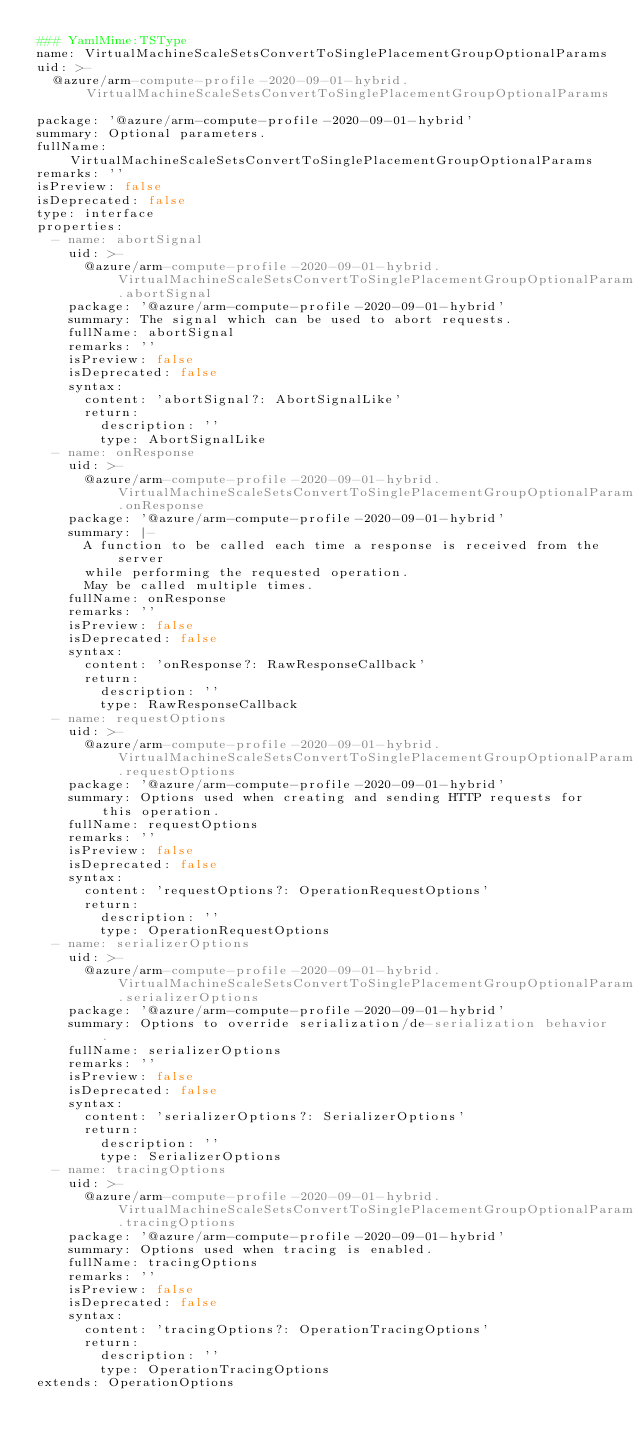Convert code to text. <code><loc_0><loc_0><loc_500><loc_500><_YAML_>### YamlMime:TSType
name: VirtualMachineScaleSetsConvertToSinglePlacementGroupOptionalParams
uid: >-
  @azure/arm-compute-profile-2020-09-01-hybrid.VirtualMachineScaleSetsConvertToSinglePlacementGroupOptionalParams
package: '@azure/arm-compute-profile-2020-09-01-hybrid'
summary: Optional parameters.
fullName: VirtualMachineScaleSetsConvertToSinglePlacementGroupOptionalParams
remarks: ''
isPreview: false
isDeprecated: false
type: interface
properties:
  - name: abortSignal
    uid: >-
      @azure/arm-compute-profile-2020-09-01-hybrid.VirtualMachineScaleSetsConvertToSinglePlacementGroupOptionalParams.abortSignal
    package: '@azure/arm-compute-profile-2020-09-01-hybrid'
    summary: The signal which can be used to abort requests.
    fullName: abortSignal
    remarks: ''
    isPreview: false
    isDeprecated: false
    syntax:
      content: 'abortSignal?: AbortSignalLike'
      return:
        description: ''
        type: AbortSignalLike
  - name: onResponse
    uid: >-
      @azure/arm-compute-profile-2020-09-01-hybrid.VirtualMachineScaleSetsConvertToSinglePlacementGroupOptionalParams.onResponse
    package: '@azure/arm-compute-profile-2020-09-01-hybrid'
    summary: |-
      A function to be called each time a response is received from the server
      while performing the requested operation.
      May be called multiple times.
    fullName: onResponse
    remarks: ''
    isPreview: false
    isDeprecated: false
    syntax:
      content: 'onResponse?: RawResponseCallback'
      return:
        description: ''
        type: RawResponseCallback
  - name: requestOptions
    uid: >-
      @azure/arm-compute-profile-2020-09-01-hybrid.VirtualMachineScaleSetsConvertToSinglePlacementGroupOptionalParams.requestOptions
    package: '@azure/arm-compute-profile-2020-09-01-hybrid'
    summary: Options used when creating and sending HTTP requests for this operation.
    fullName: requestOptions
    remarks: ''
    isPreview: false
    isDeprecated: false
    syntax:
      content: 'requestOptions?: OperationRequestOptions'
      return:
        description: ''
        type: OperationRequestOptions
  - name: serializerOptions
    uid: >-
      @azure/arm-compute-profile-2020-09-01-hybrid.VirtualMachineScaleSetsConvertToSinglePlacementGroupOptionalParams.serializerOptions
    package: '@azure/arm-compute-profile-2020-09-01-hybrid'
    summary: Options to override serialization/de-serialization behavior.
    fullName: serializerOptions
    remarks: ''
    isPreview: false
    isDeprecated: false
    syntax:
      content: 'serializerOptions?: SerializerOptions'
      return:
        description: ''
        type: SerializerOptions
  - name: tracingOptions
    uid: >-
      @azure/arm-compute-profile-2020-09-01-hybrid.VirtualMachineScaleSetsConvertToSinglePlacementGroupOptionalParams.tracingOptions
    package: '@azure/arm-compute-profile-2020-09-01-hybrid'
    summary: Options used when tracing is enabled.
    fullName: tracingOptions
    remarks: ''
    isPreview: false
    isDeprecated: false
    syntax:
      content: 'tracingOptions?: OperationTracingOptions'
      return:
        description: ''
        type: OperationTracingOptions
extends: OperationOptions
</code> 